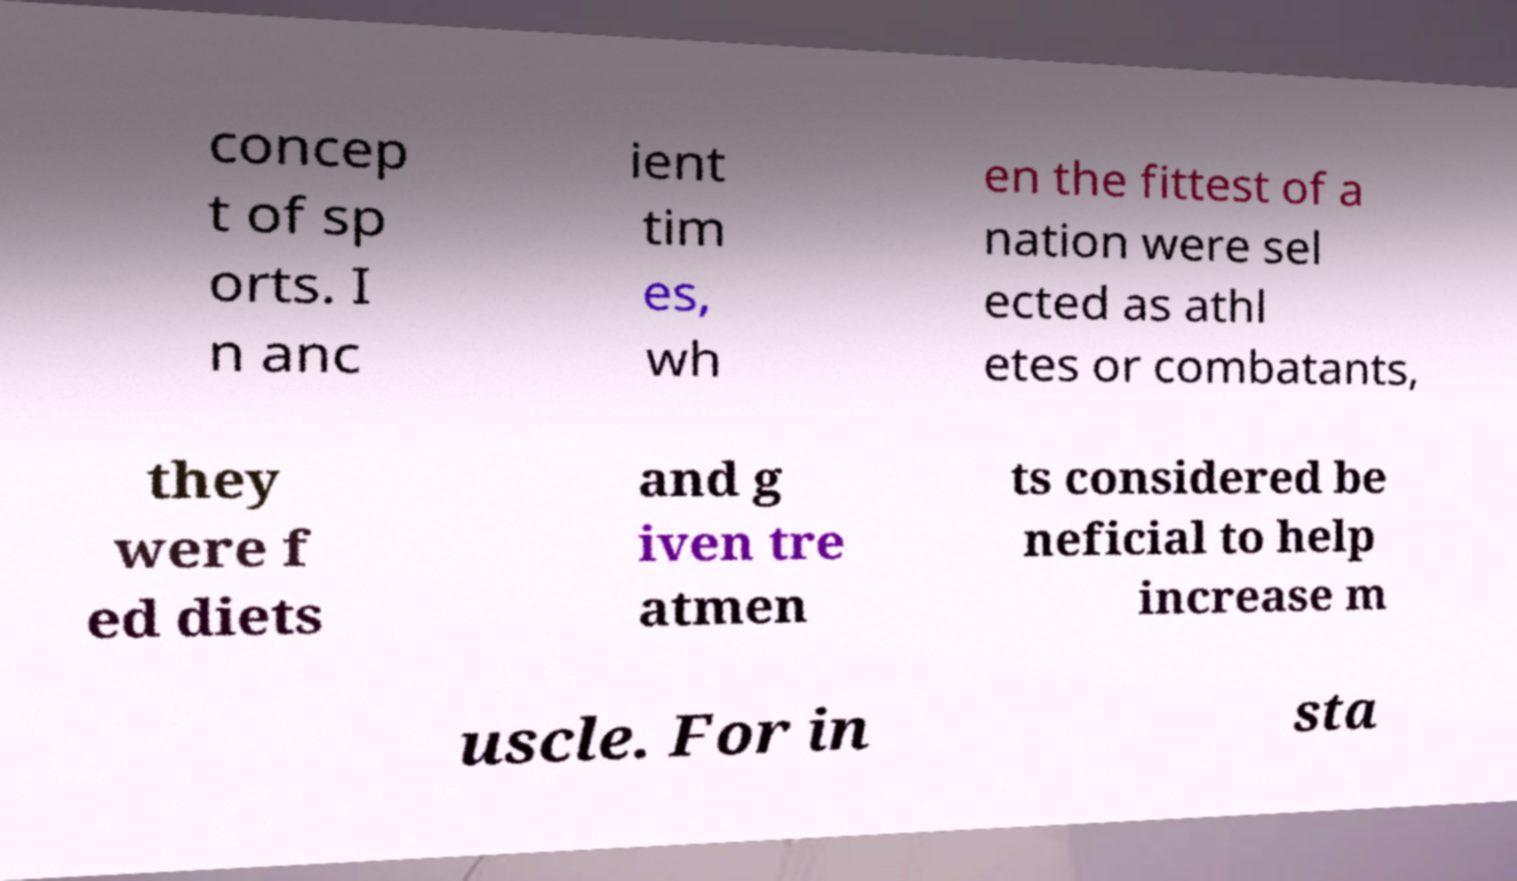Can you read and provide the text displayed in the image?This photo seems to have some interesting text. Can you extract and type it out for me? concep t of sp orts. I n anc ient tim es, wh en the fittest of a nation were sel ected as athl etes or combatants, they were f ed diets and g iven tre atmen ts considered be neficial to help increase m uscle. For in sta 